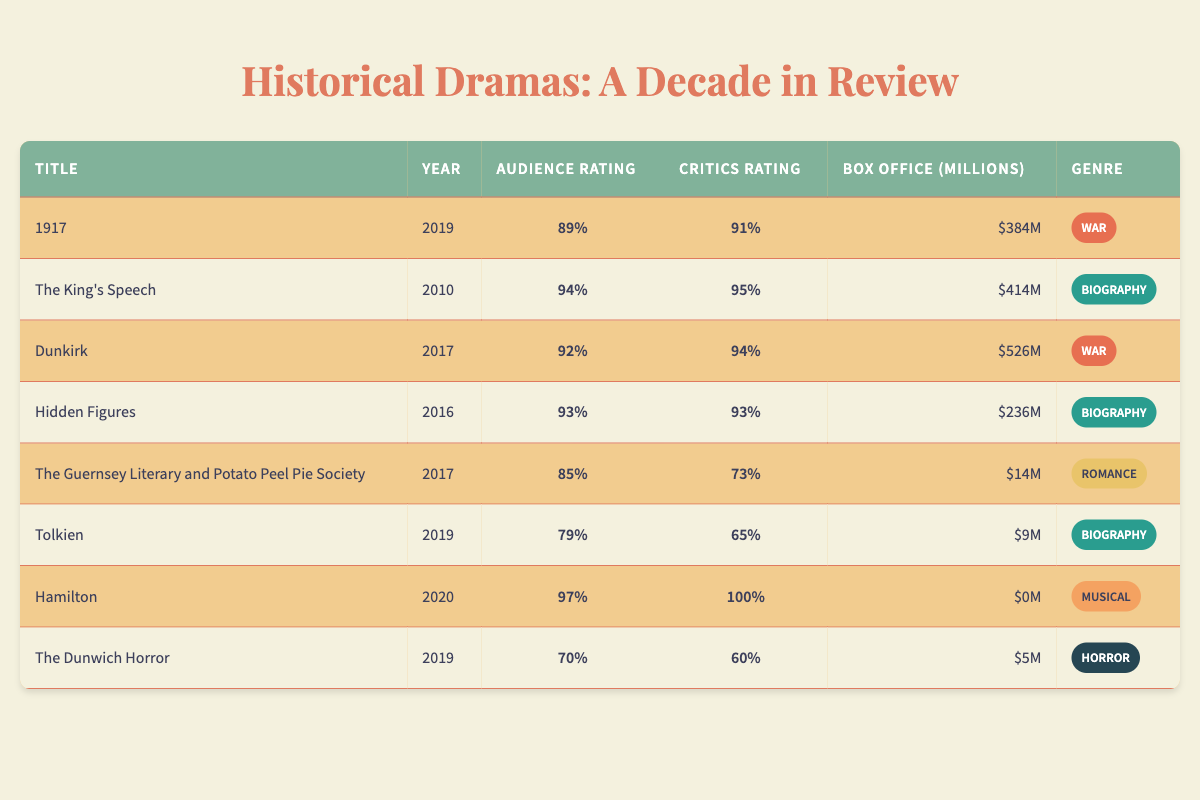What is the highest audience rating among the historical dramas listed? The highest audience rating is found in the row for "Hamilton," which has an audience rating of 97%.
Answer: 97% Which historical drama had the lowest box office earnings? The historical drama with the lowest box office earnings is "Tolkien," which earned $9 million.
Answer: $9 million What is the average audience rating for the films categorized as "War"? The audience ratings for the War films are 89% (1917) and 92% (Dunkirk). The average is calculated as (89 + 92) / 2 = 90.5%.
Answer: 90.5% Did "The King's Speech" receive a higher rating from critics compared to its audience rating? "The King's Speech" has a critics rating of 95%, which is greater than its audience rating of 94%.
Answer: Yes Which genre has the highest average box office earnings? To determine this, we must calculate the box office earnings for each genre: War ($384M + $526M = $910M), Biography ($414M + $236M + $9M = $659M), Romance ($14M), Musical ($0M), and Horror ($5M). The averages are War: 910M/2 = $455M; Biography: 659M/3 = $219.67M; Romance: $14M; Musical: $0M; Horror: $5M. Therefore, War has the highest average box office.
Answer: War Is it true that all films released in 2019 had audience ratings below 90%? In 2019, "1917" had an audience rating of 89%, and "Hamilton" had an audience rating of 97%, so not all films from that year had below 90%.
Answer: No 